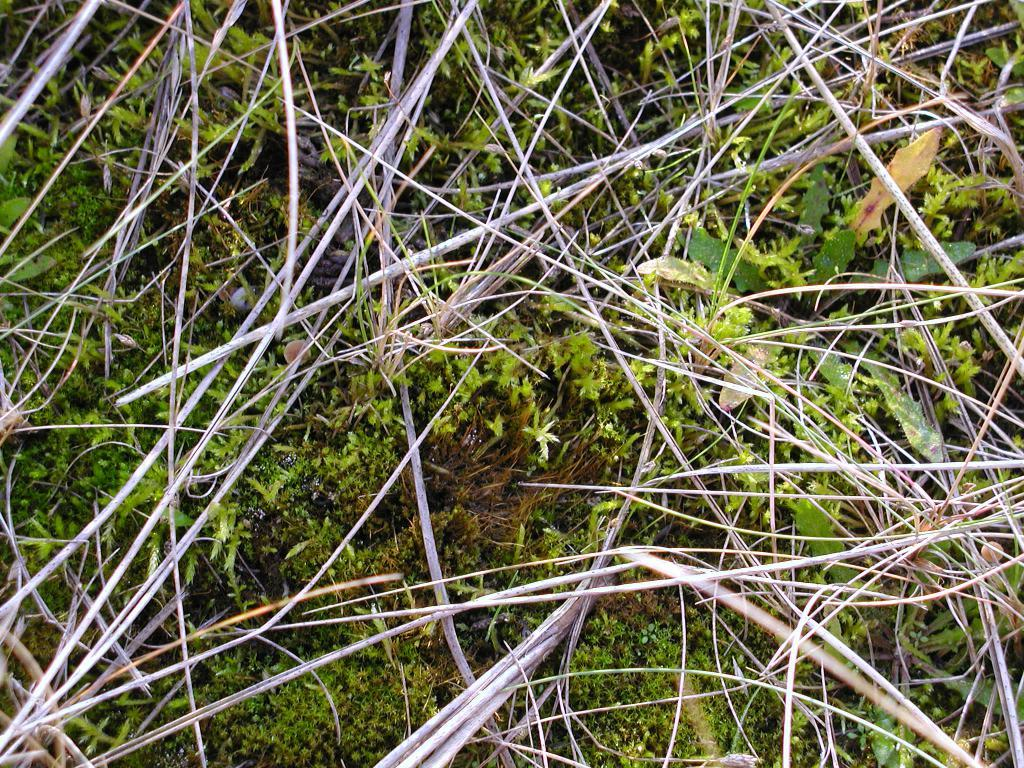What type of objects are in the image? There are wooden twigs in the image. What can be seen in the background of the image? The background of the image includes grass. What is the color of the grass in the image? The grass is green in color. How many clocks are visible in the image? There are no clocks present in the image. What type of boundary can be seen in the image? There is no boundary visible in the image; it features wooden twigs and green grass. 